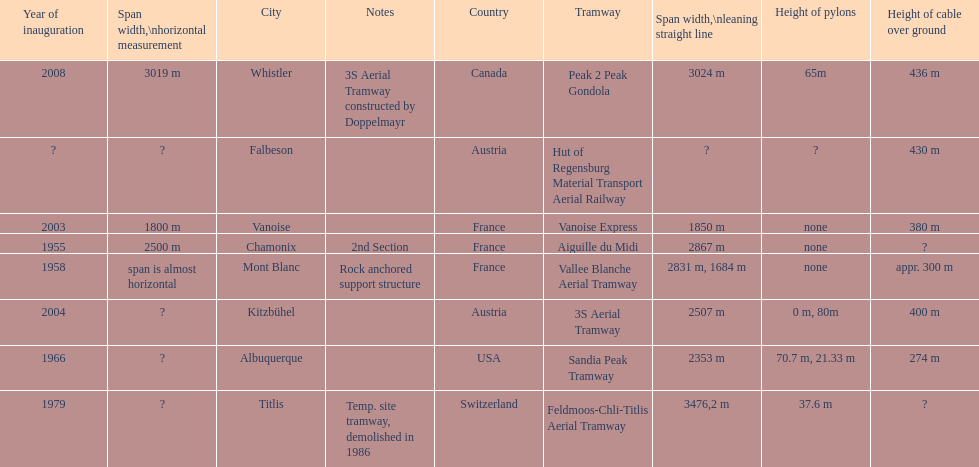Was the sandia peak tramway innagurate before or after the 3s aerial tramway? Before. 